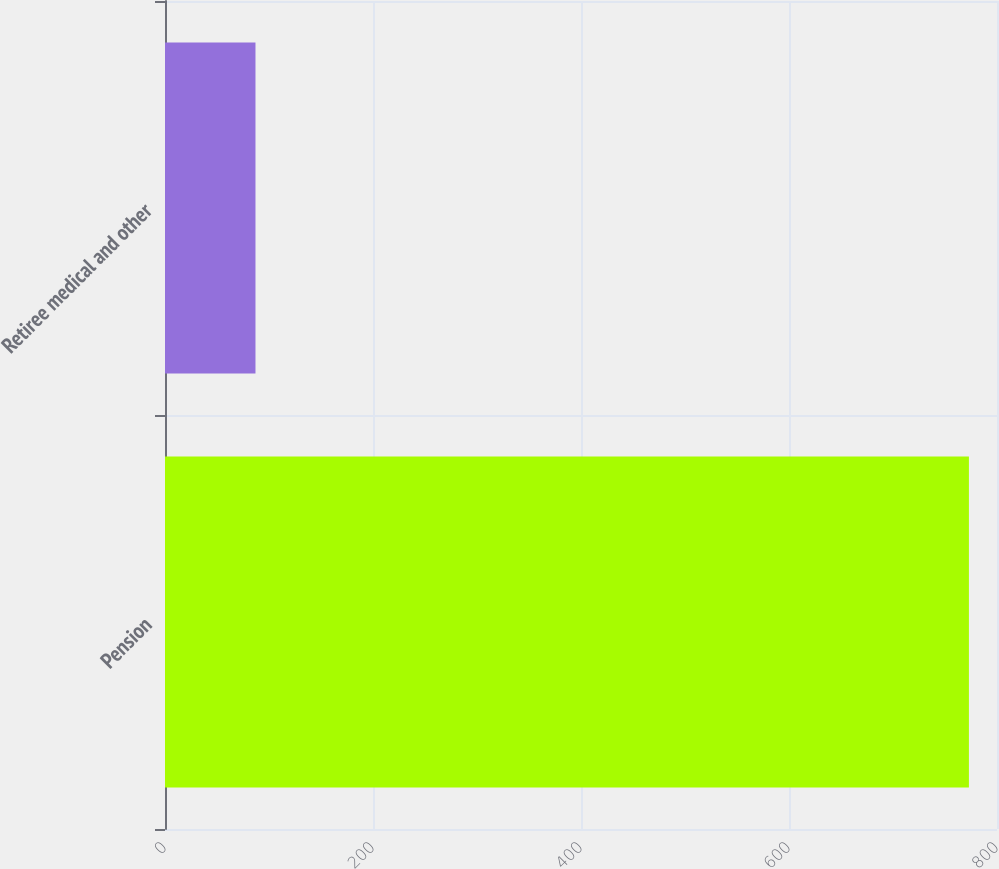Convert chart to OTSL. <chart><loc_0><loc_0><loc_500><loc_500><bar_chart><fcel>Pension<fcel>Retiree medical and other<nl><fcel>773<fcel>87<nl></chart> 